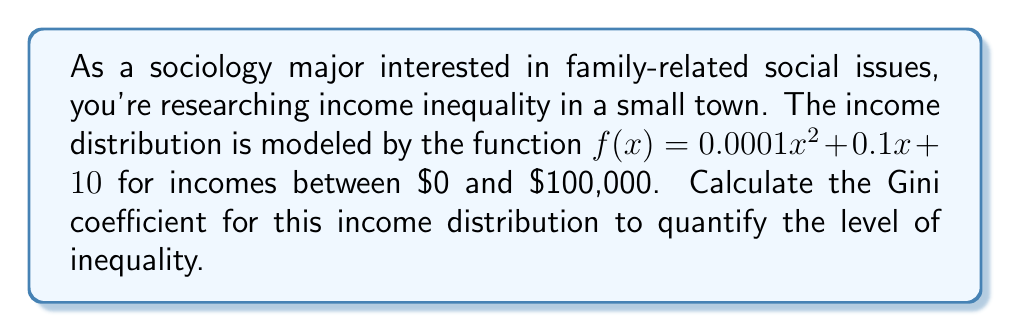Can you solve this math problem? To calculate the Gini coefficient, we'll follow these steps:

1) The Gini coefficient is defined as the ratio of the area between the Lorenz curve and the line of perfect equality to the total area under the line of perfect equality.

2) First, we need to find the total income:
   $$\text{Total Income} = \int_0^{100000} (0.0001x^2 + 0.1x + 10) dx$$
   $$= [0.0001\frac{x^3}{3} + 0.1\frac{x^2}{2} + 10x]_0^{100000}$$
   $$= 3.33 \times 10^{11} + 5 \times 10^8 + 10^6 = 3.33667 \times 10^{11}$$

3) Next, we calculate the cumulative income function:
   $$F(y) = \int_0^y (0.0001x^2 + 0.1x + 10) dx$$
   $$= 0.0001\frac{y^3}{3} + 0.1\frac{y^2}{2} + 10y$$

4) The Lorenz curve is given by:
   $$L(p) = \frac{F(100000p)}{3.33667 \times 10^{11}}$$

5) The Gini coefficient is calculated as:
   $$G = 1 - 2\int_0^1 L(p) dp$$

6) Substituting and simplifying:
   $$G = 1 - 2\int_0^1 \frac{0.0001\frac{(100000p)^3}{3} + 0.1\frac{(100000p)^2}{2} + 10(100000p)}{3.33667 \times 10^{11}} dp$$
   $$= 1 - 2\int_0^1 (\frac{p^3}{3} + \frac{p^2}{2} + \frac{p}{3.33667}) dp$$
   $$= 1 - 2[\frac{p^4}{12} + \frac{p^3}{6} + \frac{p^2}{6.67334}]_0^1$$
   $$= 1 - 2(0.08333 + 0.16667 + 0.14988)$$
   $$= 1 - 0.79976 = 0.20024$$

Thus, the Gini coefficient is approximately 0.20024.
Answer: 0.20024 